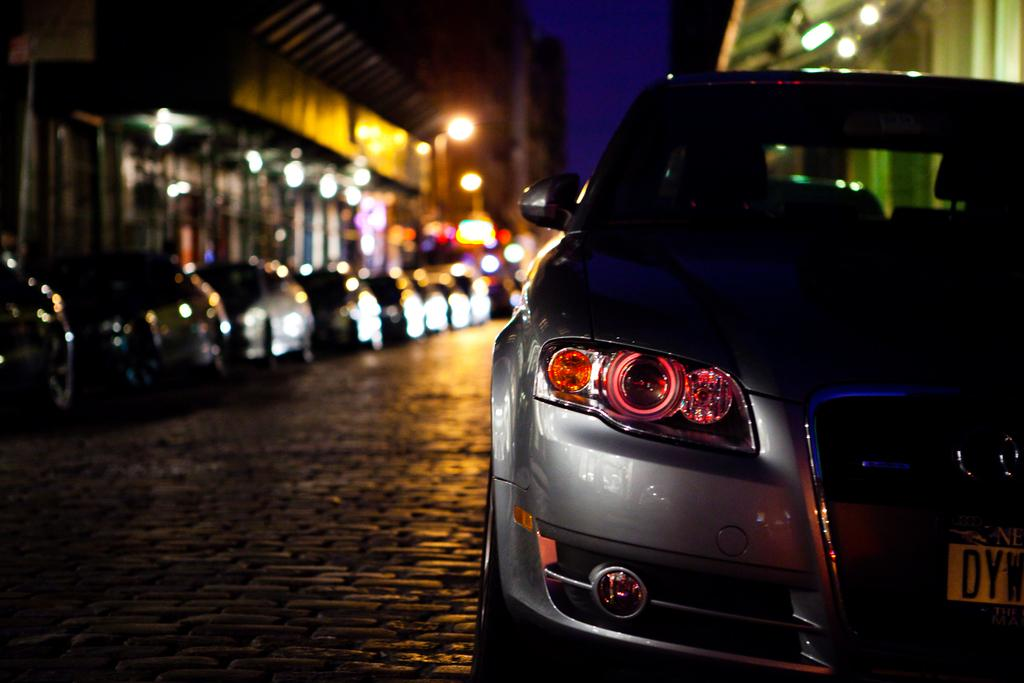What can be seen on the road in the image? There is a group of cars parked on the road. What is visible in the background of the image? There are buildings and the sky visible in the background of the image. What type of berry can be seen growing on the cars in the image? There are no berries present in the image, and the cars are parked on the road, not growing any plants. 